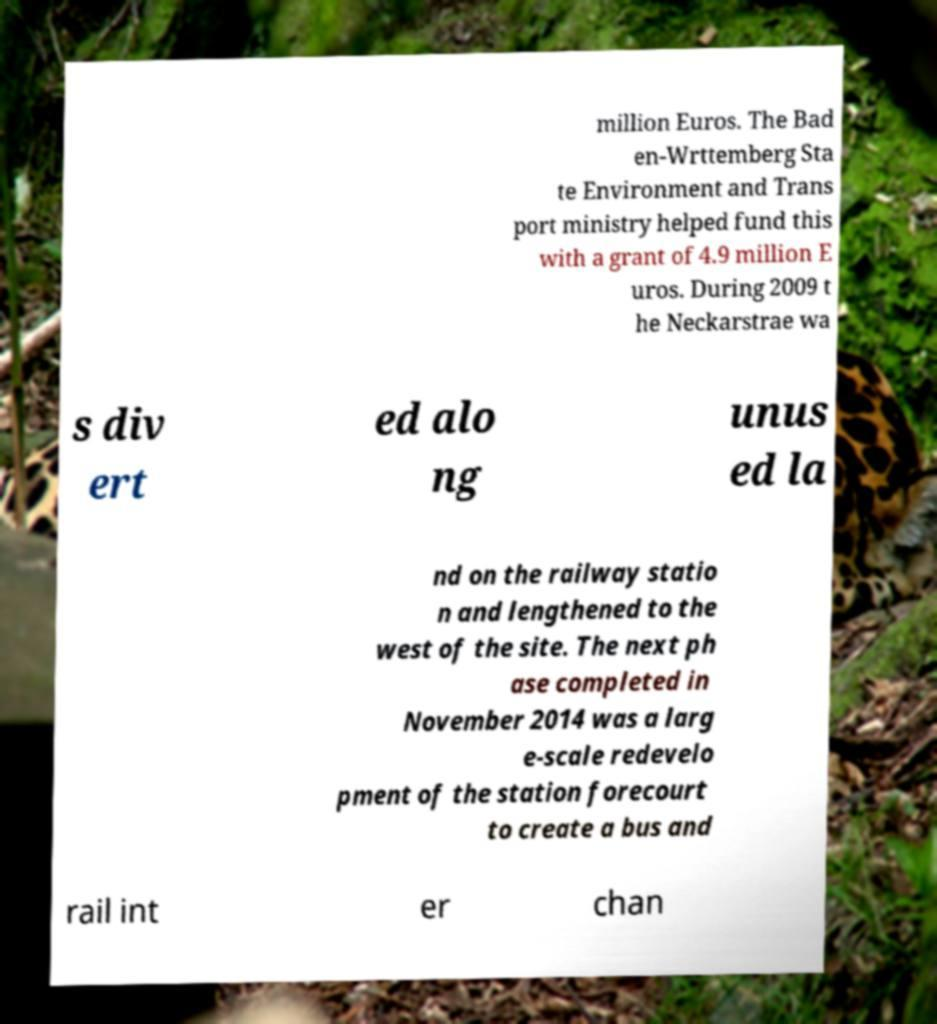Please read and relay the text visible in this image. What does it say? million Euros. The Bad en-Wrttemberg Sta te Environment and Trans port ministry helped fund this with a grant of 4.9 million E uros. During 2009 t he Neckarstrae wa s div ert ed alo ng unus ed la nd on the railway statio n and lengthened to the west of the site. The next ph ase completed in November 2014 was a larg e-scale redevelo pment of the station forecourt to create a bus and rail int er chan 